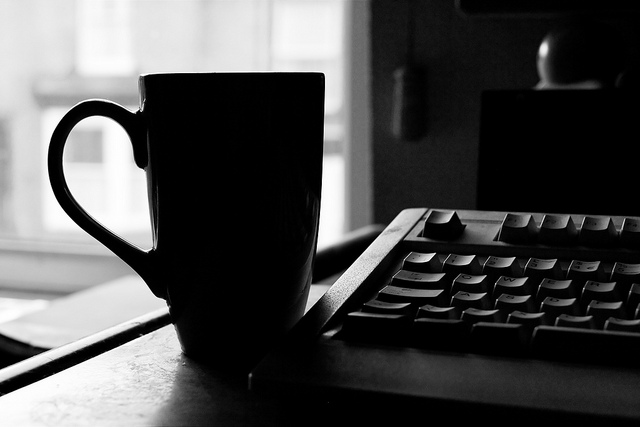<image>What brand keyboard is featured? I don't know the brand of the keyboard. It can be Dell or Sony. What brand keyboard is featured? I don't know what brand keyboard is featured in the image. It is hard to tell. 